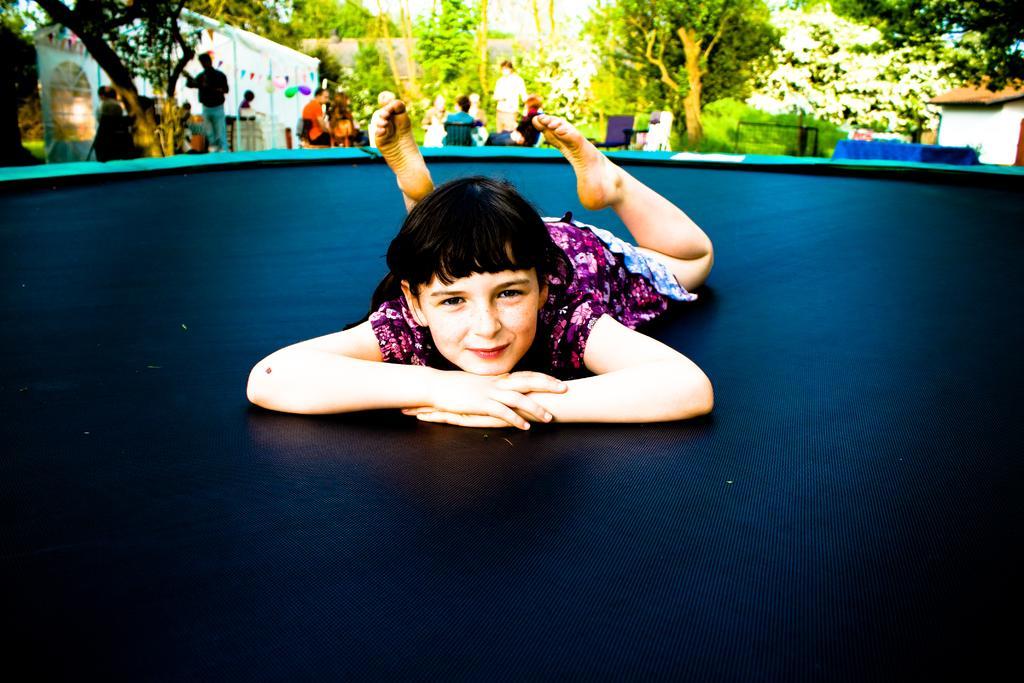Could you give a brief overview of what you see in this image? In the picture we can see a kid wearing multi color dress lying on surface and in the background of the picture there are some persons standing and some are sitting on chairs, there are some trees and top of the picture there is clear sky. 